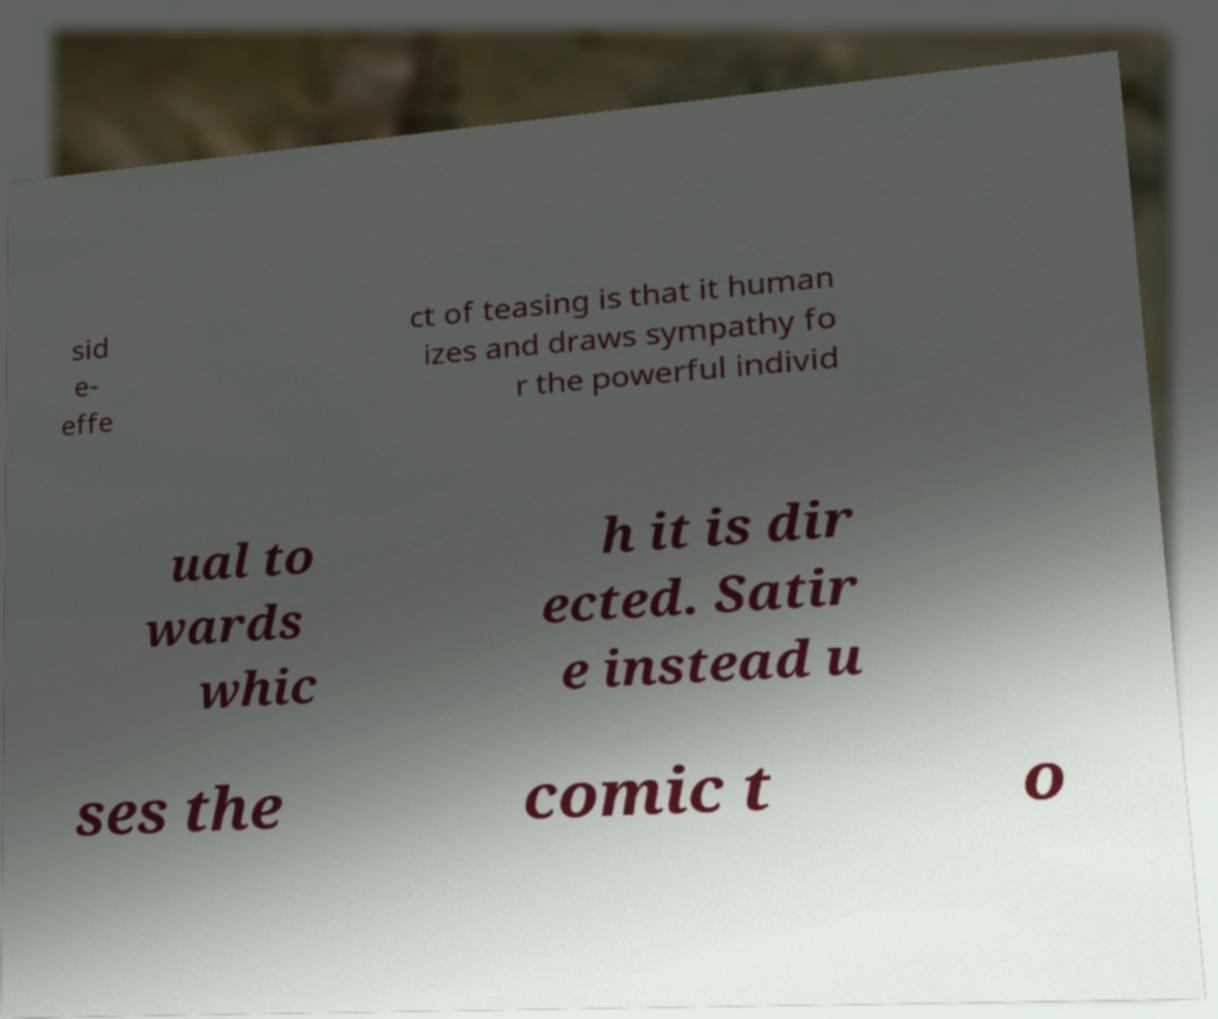Can you accurately transcribe the text from the provided image for me? sid e- effe ct of teasing is that it human izes and draws sympathy fo r the powerful individ ual to wards whic h it is dir ected. Satir e instead u ses the comic t o 